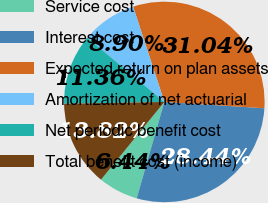<chart> <loc_0><loc_0><loc_500><loc_500><pie_chart><fcel>Service cost<fcel>Interest cost<fcel>Expected return on plan assets<fcel>Amortization of net actuarial<fcel>Net periodic benefit cost<fcel>Total benefit cost (income)<nl><fcel>6.44%<fcel>28.44%<fcel>31.04%<fcel>8.9%<fcel>11.36%<fcel>13.82%<nl></chart> 